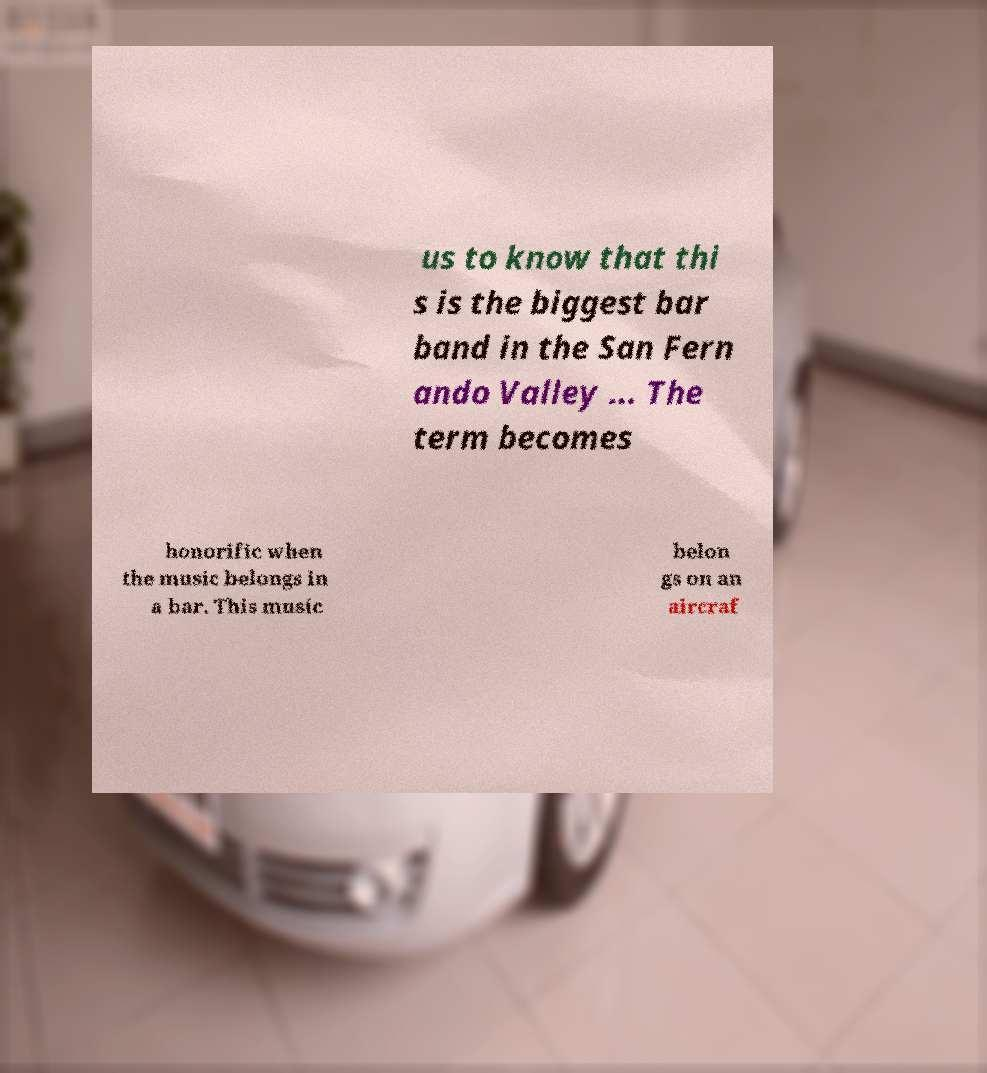There's text embedded in this image that I need extracted. Can you transcribe it verbatim? us to know that thi s is the biggest bar band in the San Fern ando Valley ... The term becomes honorific when the music belongs in a bar. This music belon gs on an aircraf 